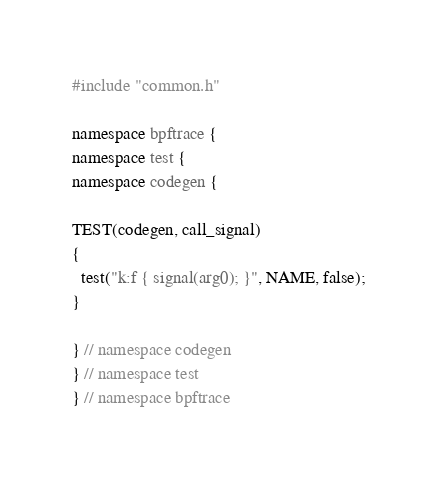<code> <loc_0><loc_0><loc_500><loc_500><_C++_>#include "common.h"

namespace bpftrace {
namespace test {
namespace codegen {

TEST(codegen, call_signal)
{
  test("k:f { signal(arg0); }", NAME, false);
}

} // namespace codegen
} // namespace test
} // namespace bpftrace
</code> 